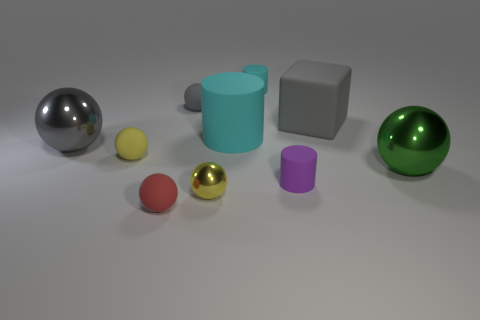What is the shape of the small object that is the same color as the rubber block?
Offer a very short reply. Sphere. What number of other big matte cylinders are the same color as the large cylinder?
Your answer should be very brief. 0. Are there fewer metal things left of the big green shiny sphere than tiny rubber things?
Your answer should be compact. Yes. Are there any green metallic balls that have the same size as the gray matte cube?
Make the answer very short. Yes. What is the color of the small shiny thing?
Your answer should be compact. Yellow. Is the yellow metal ball the same size as the green thing?
Provide a short and direct response. No. How many things are cylinders or large green shiny spheres?
Keep it short and to the point. 4. Is the number of metallic things that are in front of the purple matte thing the same as the number of tiny cylinders?
Keep it short and to the point. No. Are there any small purple objects behind the small yellow object that is in front of the big metallic thing to the right of the large rubber cylinder?
Make the answer very short. Yes. The cube that is the same material as the small purple thing is what color?
Provide a short and direct response. Gray. 